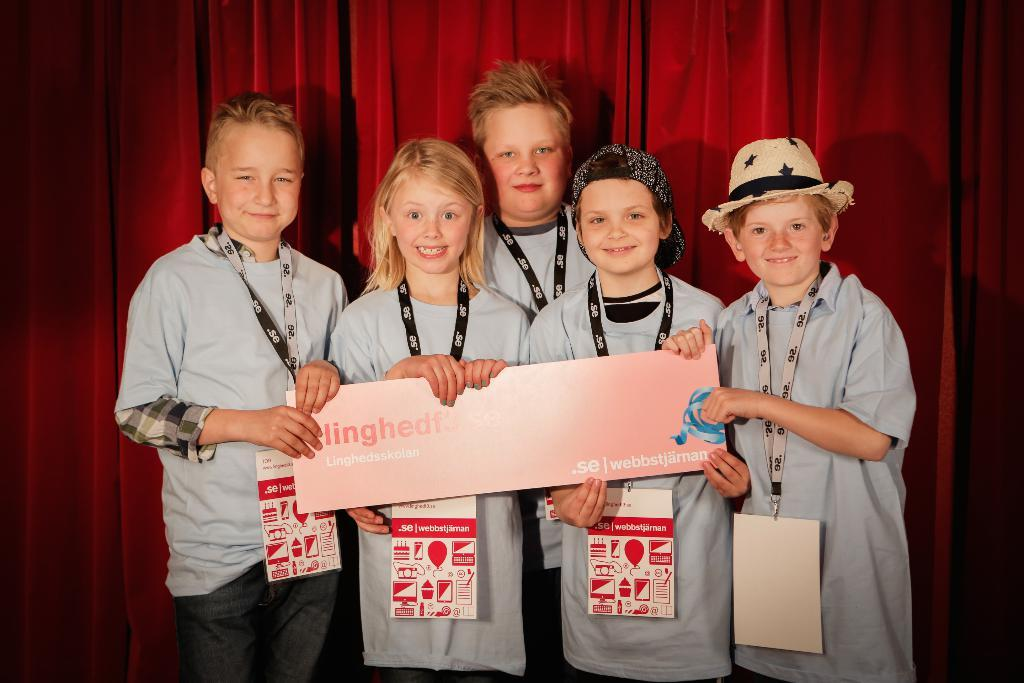What is the main subject of the image? The main subject of the image is the children. What are the children wearing in the image? The children are wearing ID cards. What are the children holding in the image? The children are holding a board with some text. What can be seen in the background of the image? There is a red color curtain in the background of the image. Can you see any scissors in the image? There are no scissors visible in the image. What type of cave is depicted in the background of the image? There is no cave present in the image; it features a red color curtain in the background. 